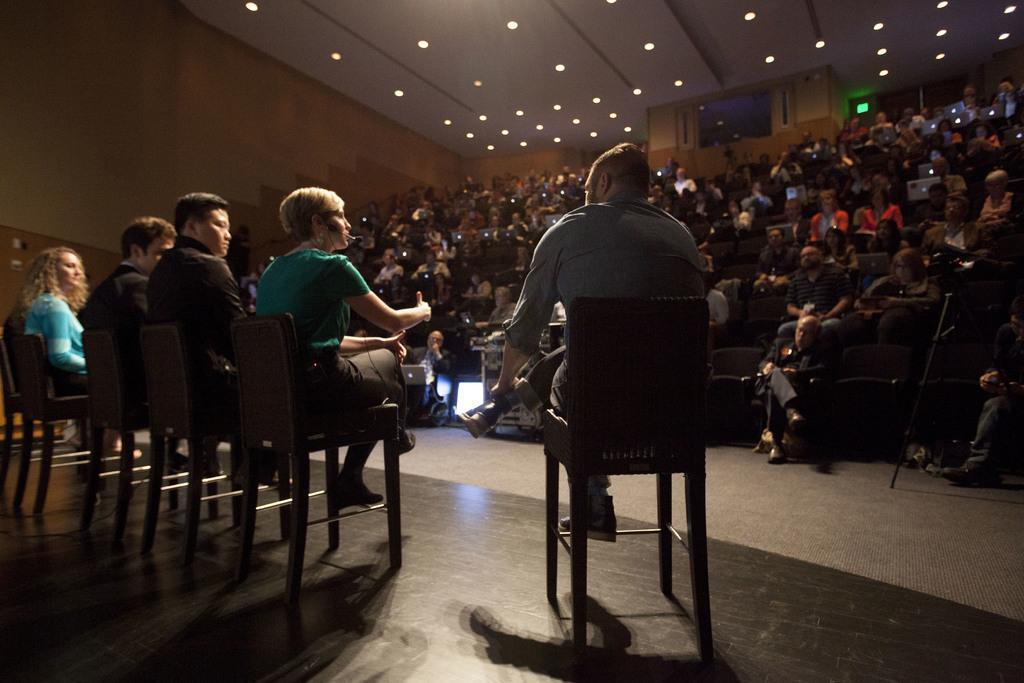In one or two sentences, can you explain what this image depicts? In this picture we can see group of people, they are sitting on the chairs and few people holding laptops, in the background we can see few lights. 